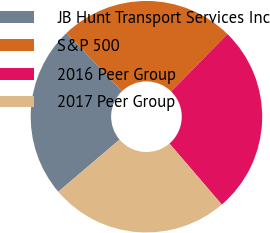Convert chart to OTSL. <chart><loc_0><loc_0><loc_500><loc_500><pie_chart><fcel>JB Hunt Transport Services Inc<fcel>S&P 500<fcel>2016 Peer Group<fcel>2017 Peer Group<nl><fcel>24.08%<fcel>24.48%<fcel>26.37%<fcel>25.06%<nl></chart> 